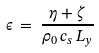Convert formula to latex. <formula><loc_0><loc_0><loc_500><loc_500>\epsilon \, = \, \frac { \eta + \zeta } { \rho _ { 0 } \, c _ { s } \, L _ { y } }</formula> 